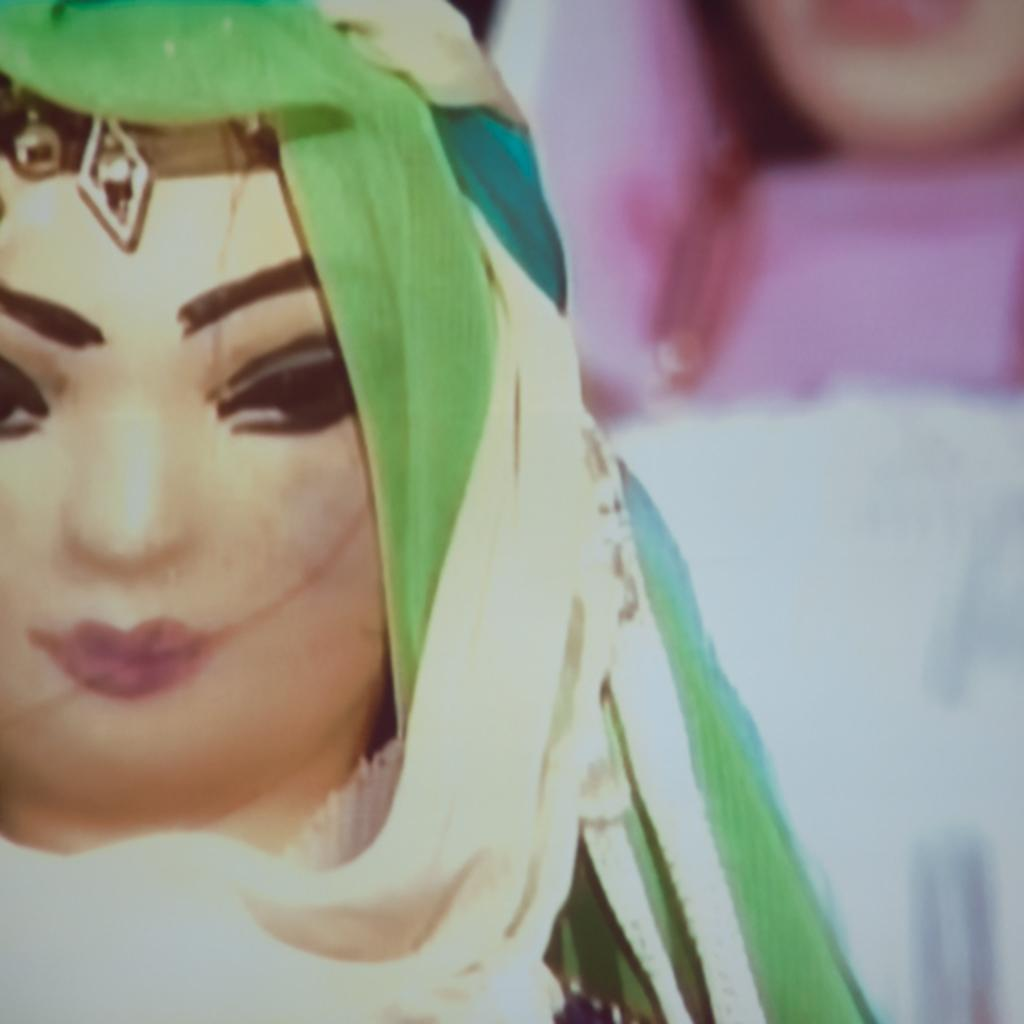What is the main object in the image? There is a toy in the image. Can you describe the background of the image? The background of the image is blurry. How much cream is on the toy in the image? There is no cream present on the toy in the image. 